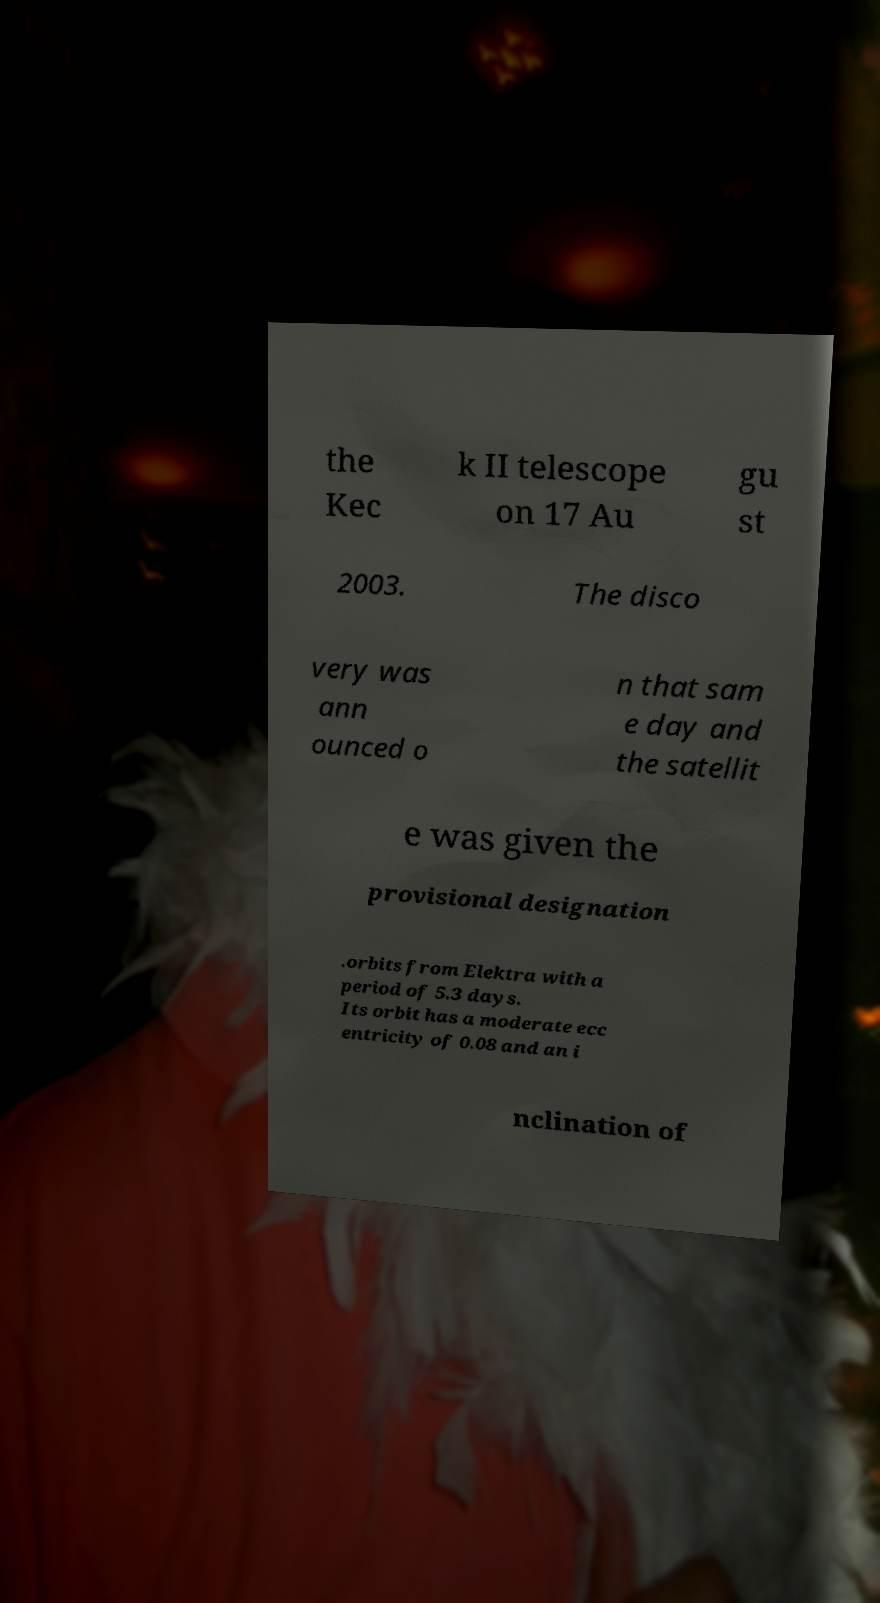Could you extract and type out the text from this image? the Kec k II telescope on 17 Au gu st 2003. The disco very was ann ounced o n that sam e day and the satellit e was given the provisional designation .orbits from Elektra with a period of 5.3 days. Its orbit has a moderate ecc entricity of 0.08 and an i nclination of 